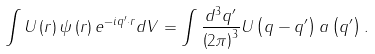Convert formula to latex. <formula><loc_0><loc_0><loc_500><loc_500>\int U \left ( r \right ) \psi \left ( r \right ) e ^ { - i q ^ { \prime } \cdot r } d V = \int \frac { d ^ { 3 } q ^ { \prime } } { \left ( 2 \pi \right ) ^ { 3 } } U \left ( q - q ^ { \prime } \right ) a \left ( q ^ { \prime } \right ) .</formula> 